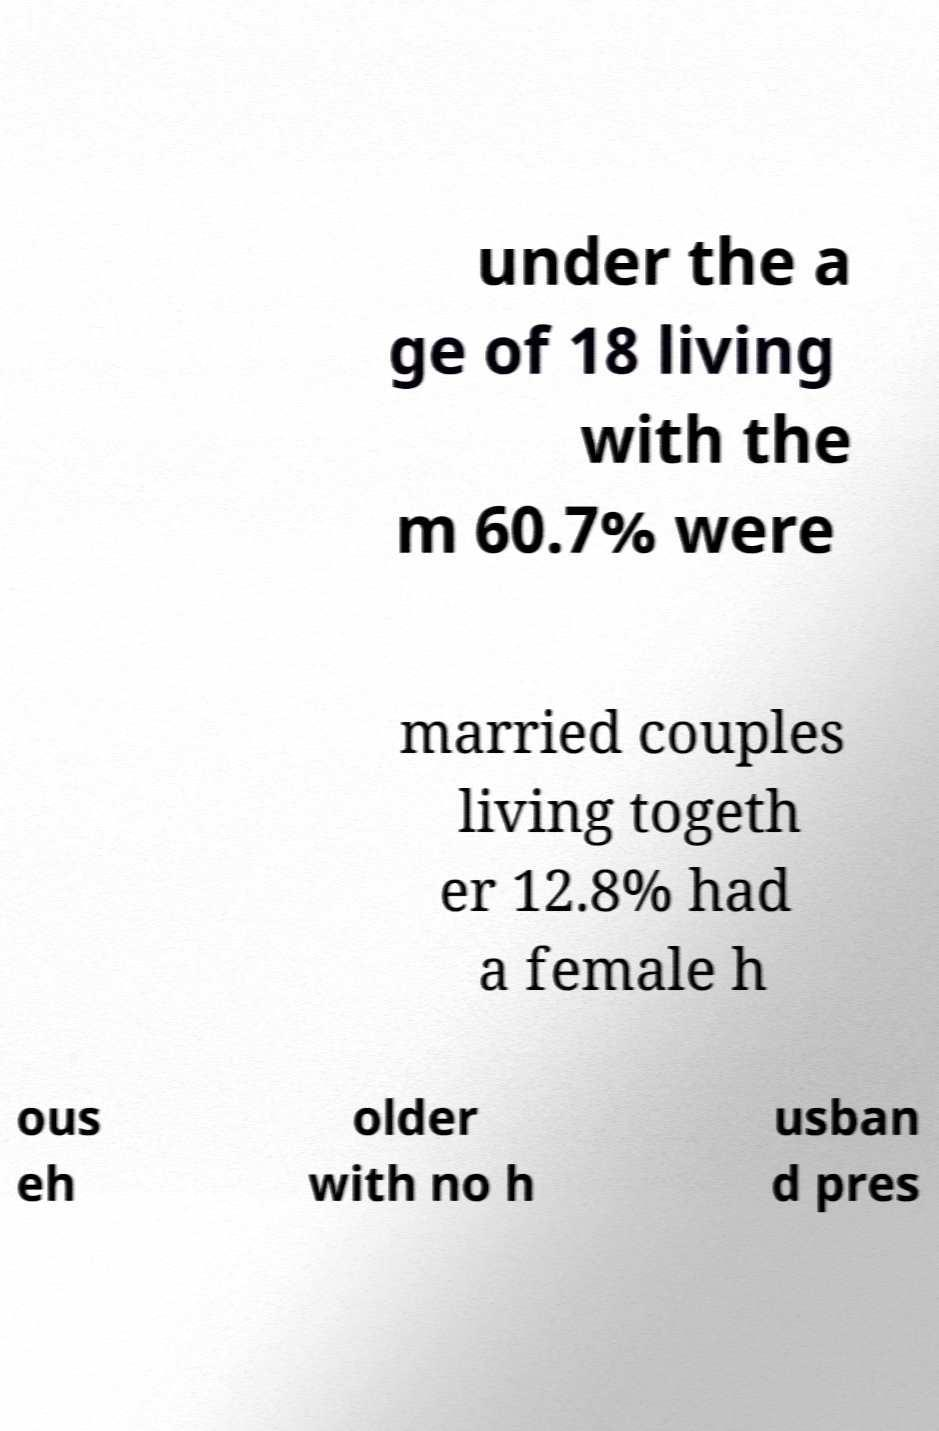Could you assist in decoding the text presented in this image and type it out clearly? under the a ge of 18 living with the m 60.7% were married couples living togeth er 12.8% had a female h ous eh older with no h usban d pres 